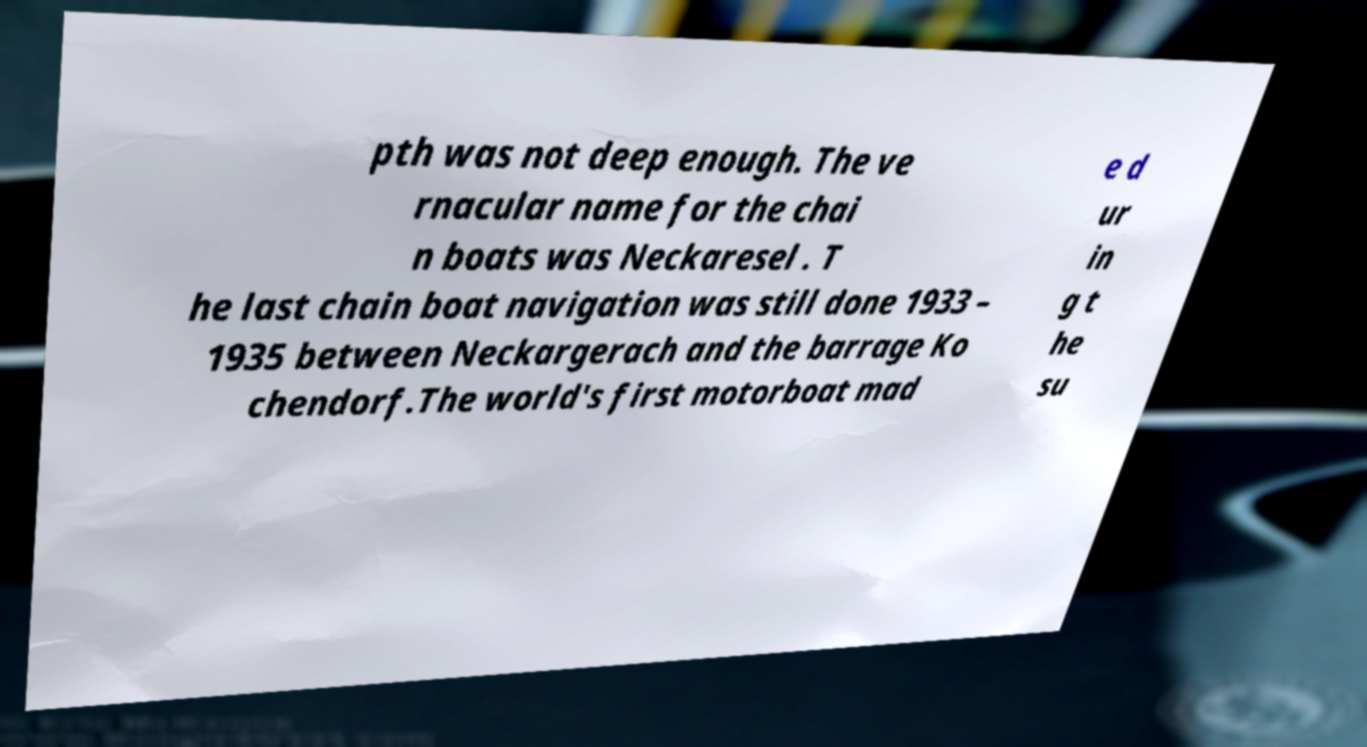For documentation purposes, I need the text within this image transcribed. Could you provide that? pth was not deep enough. The ve rnacular name for the chai n boats was Neckaresel . T he last chain boat navigation was still done 1933 – 1935 between Neckargerach and the barrage Ko chendorf.The world's first motorboat mad e d ur in g t he su 